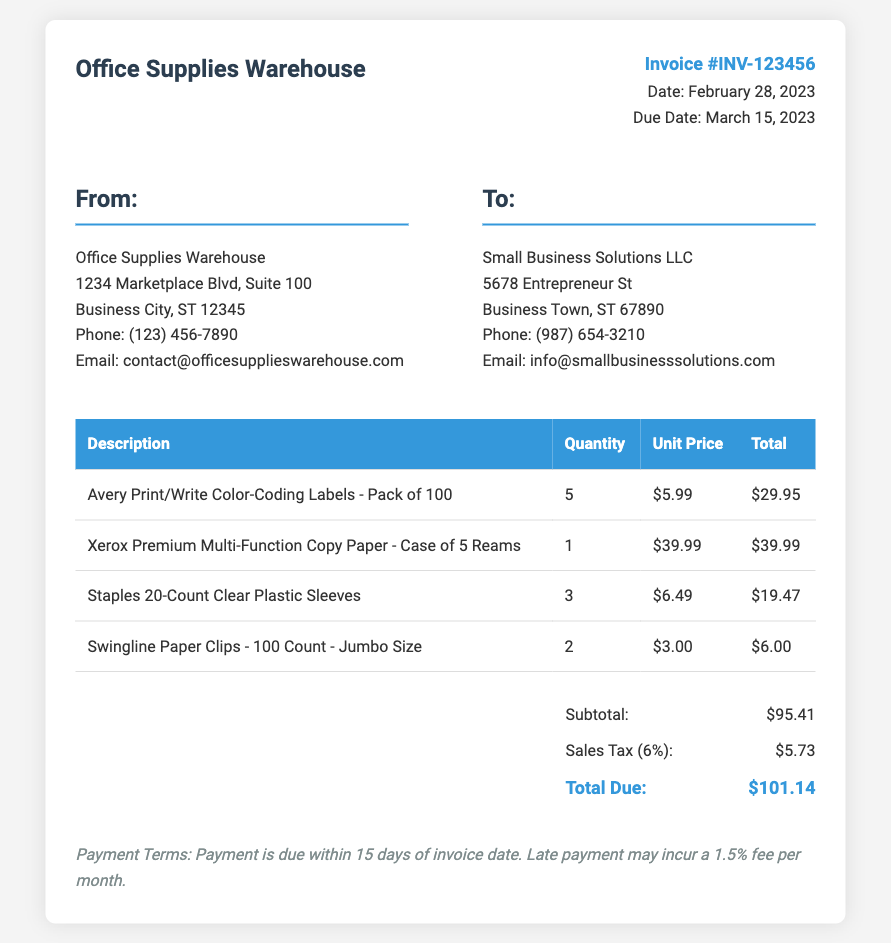What is the invoice number? The invoice number is displayed prominently in the invoice details section.
Answer: INV-123456 When was the invoice issued? The invoice date is mentioned in the invoice details section.
Answer: February 28, 2023 What is the total amount due? The total due is calculated by adding the subtotal and sales tax.
Answer: $101.14 What is the sales tax percentage applied? The sales tax rate is specified in the total amount section.
Answer: 6% How many units of Avery labels were purchased? The quantity of Avery labels is shown in the itemized list of purchased supplies.
Answer: 5 What payment term is specified for this invoice? The payment terms are outlined at the bottom of the invoice.
Answer: Payment is due within 15 days What is the subtotal amount before tax? The subtotal is listed separately in the total section of the invoice.
Answer: $95.41 Who is the seller in this transaction? The seller's name is provided at the top of the invoice.
Answer: Office Supplies Warehouse What is the due date for this invoice? The due date is clearly mentioned in the invoice details section.
Answer: March 15, 2023 How many types of office supplies were listed in the invoice? The invoice contains an itemized list which enumerates the different types of supplies.
Answer: 4 